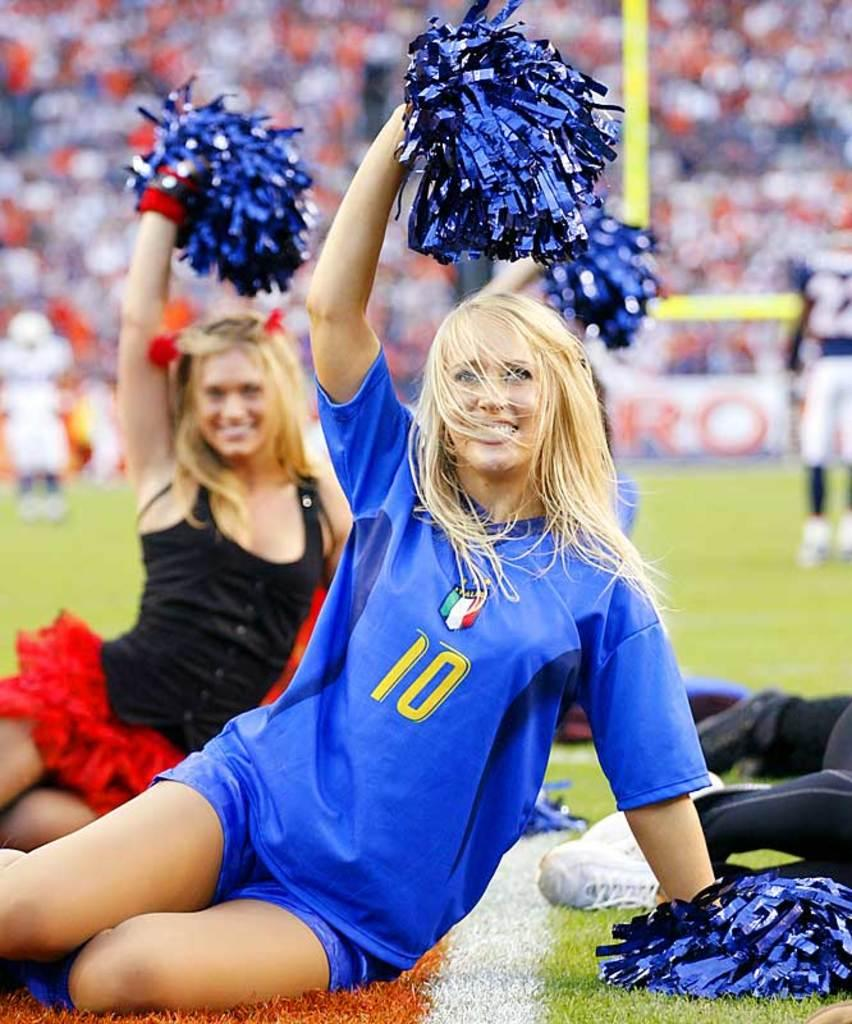<image>
Offer a succinct explanation of the picture presented. Girls sitting on a football field in a row and the first girl has a 10 on her shirt. 